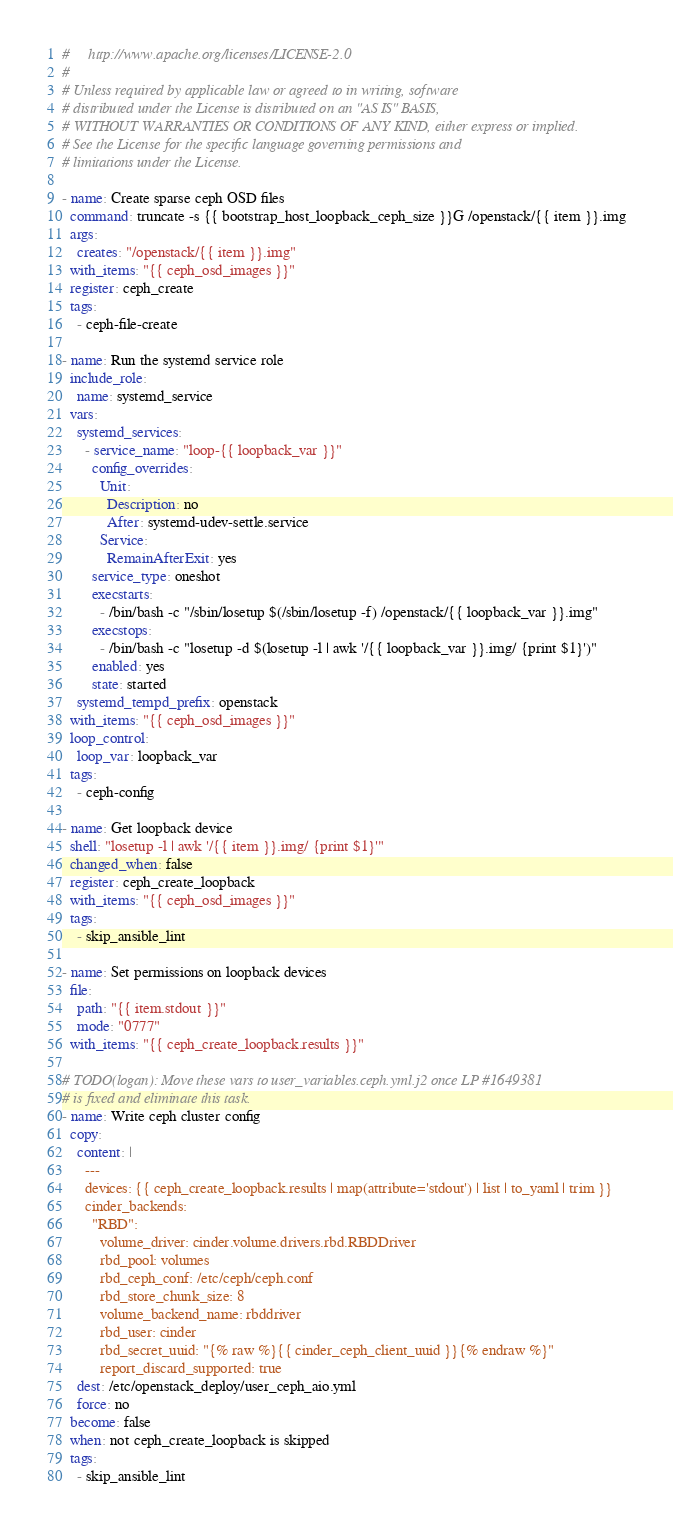<code> <loc_0><loc_0><loc_500><loc_500><_YAML_>#     http://www.apache.org/licenses/LICENSE-2.0
#
# Unless required by applicable law or agreed to in writing, software
# distributed under the License is distributed on an "AS IS" BASIS,
# WITHOUT WARRANTIES OR CONDITIONS OF ANY KIND, either express or implied.
# See the License for the specific language governing permissions and
# limitations under the License.

- name: Create sparse ceph OSD files
  command: truncate -s {{ bootstrap_host_loopback_ceph_size }}G /openstack/{{ item }}.img
  args:
    creates: "/openstack/{{ item }}.img"
  with_items: "{{ ceph_osd_images }}"
  register: ceph_create
  tags:
    - ceph-file-create

- name: Run the systemd service role
  include_role:
    name: systemd_service
  vars:
    systemd_services:
      - service_name: "loop-{{ loopback_var }}"
        config_overrides:
          Unit:
            Description: no
            After: systemd-udev-settle.service
          Service:
            RemainAfterExit: yes
        service_type: oneshot
        execstarts:
          - /bin/bash -c "/sbin/losetup $(/sbin/losetup -f) /openstack/{{ loopback_var }}.img"
        execstops:
          - /bin/bash -c "losetup -d $(losetup -l | awk '/{{ loopback_var }}.img/ {print $1}')"
        enabled: yes
        state: started
    systemd_tempd_prefix: openstack
  with_items: "{{ ceph_osd_images }}"
  loop_control:
    loop_var: loopback_var
  tags:
    - ceph-config

- name: Get loopback device
  shell: "losetup -l | awk '/{{ item }}.img/ {print $1}'"
  changed_when: false
  register: ceph_create_loopback
  with_items: "{{ ceph_osd_images }}"
  tags:
    - skip_ansible_lint

- name: Set permissions on loopback devices
  file:
    path: "{{ item.stdout }}"
    mode: "0777"
  with_items: "{{ ceph_create_loopback.results }}"

# TODO(logan): Move these vars to user_variables.ceph.yml.j2 once LP #1649381
# is fixed and eliminate this task.
- name: Write ceph cluster config
  copy:
    content: |
      ---
      devices: {{ ceph_create_loopback.results | map(attribute='stdout') | list | to_yaml | trim }}
      cinder_backends:
        "RBD":
          volume_driver: cinder.volume.drivers.rbd.RBDDriver
          rbd_pool: volumes
          rbd_ceph_conf: /etc/ceph/ceph.conf
          rbd_store_chunk_size: 8
          volume_backend_name: rbddriver
          rbd_user: cinder
          rbd_secret_uuid: "{% raw %}{{ cinder_ceph_client_uuid }}{% endraw %}"
          report_discard_supported: true
    dest: /etc/openstack_deploy/user_ceph_aio.yml
    force: no
  become: false
  when: not ceph_create_loopback is skipped
  tags:
    - skip_ansible_lint
</code> 